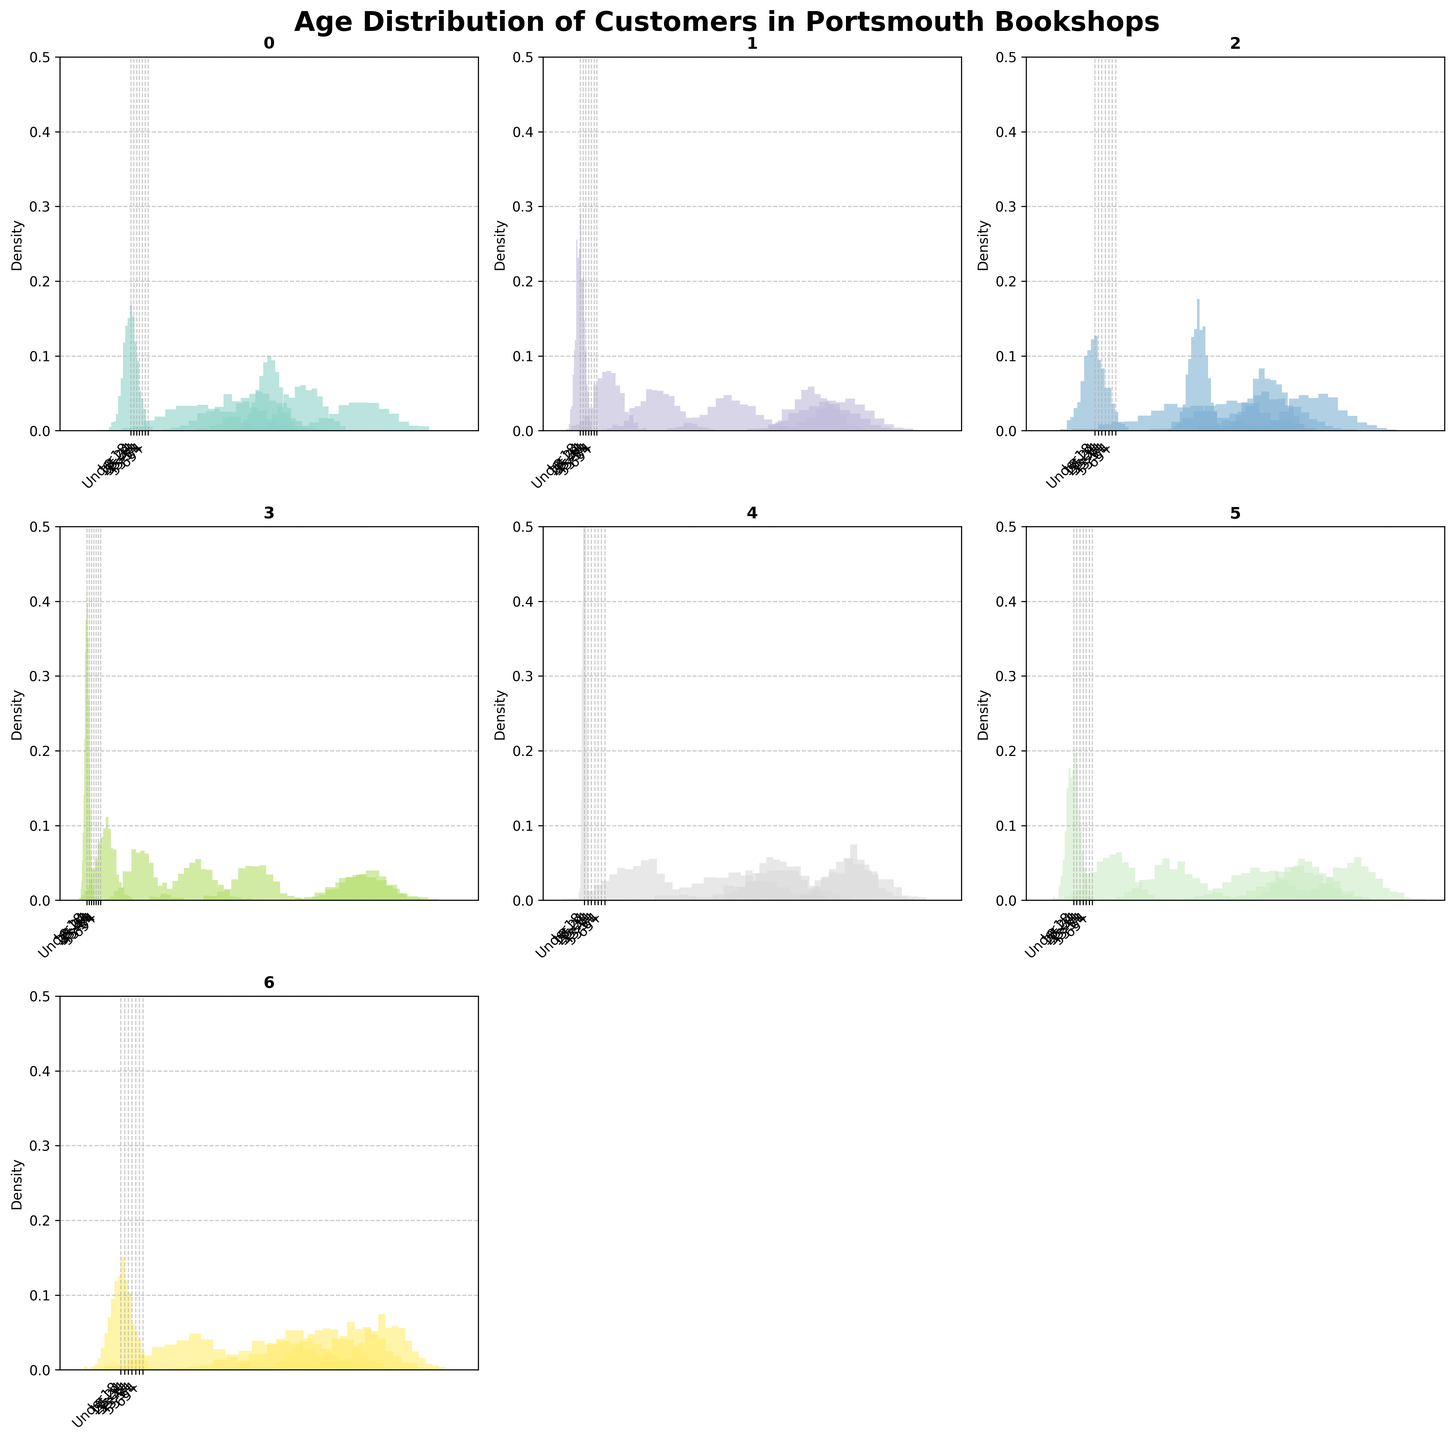At which bookshop do the '25-34' age group customers have the highest density? The highest density is found by observing which KDE distribution for the '25-34' age group has the most pronounced peak.
Answer: Adelphi Books Which bookshop has the smoothest line among all age groups? The smoothest line can be identified by looking for the distribution with the least variability and smooth transition across different age groups.
Answer: Bookends Which age group has the highest density at Southsea Books? Identify the age group that has the tallest histogram bar on Southsea Books' subplot.
Answer: 25-34 Is there any bookshop where the 'Under 18' age group density is greater than '45-54' age group density? Compare the histogram bars for 'Under 18' and '45-54' age groups across all subplots to see if one is consistently higher.
Answer: No Among 'Blackwell's Portsmouth' and 'Waterstones Portsmouth,' which has a higher density for the '18-24' age group? Compare the peaks of the histogram bars for the '18-24' age group in both 'Blackwell's Portsmouth' and 'Waterstones Portsmouth'.
Answer: Waterstones Portsmouth Which age group shows the most even density distribution across all bookshops? Assess which age group has a relatively balanced height of histogram bars across all bookshop subplots.
Answer: 35-44 How does the '65+' age group's density in 'Bookends' compare to the '35-44' age group's density in 'The Hayling Island Bookshop'? Compare the height of histogram bars for the '65+' age group in 'Bookends' with the '35-44' age group in 'The Hayling Island Bookshop'.
Answer: Bookends' '65+' is similar to 'The Hayling Island Bookshop's '35-44' What is the general trend observed for older age groups (55+) versus younger age groups (under 34) across all bookshops? Observe and compare the height of histogram bars for age groups '55-64' and '65+' against 'Under 18', '18-24', and '25-34' for all bookshops.
Answer: Older groups tend to have lower densities than younger groups Is there a bookshop where the density for age groups '18-24' and '25-34' are almost equal? Find a bookshop subplot where the heights of the histogram bars for the '18-24' and '25-34' age groups are nearly the same.
Answer: Southsea Books Which bookshop shows the highest density for the '55-64' age group? Identify which histogram bar for the '55-64' age group is the highest among all bookshop subplots.
Answer: Bookends 